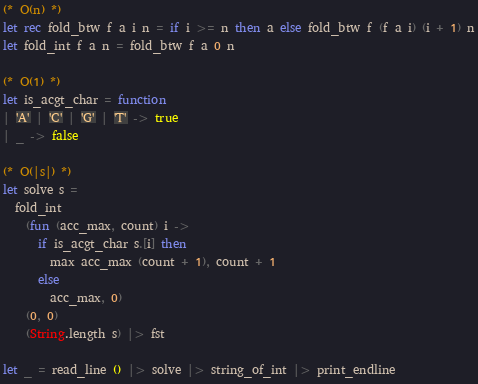<code> <loc_0><loc_0><loc_500><loc_500><_OCaml_>(* O(n) *)
let rec fold_btw f a i n = if i >= n then a else fold_btw f (f a i) (i + 1) n
let fold_int f a n = fold_btw f a 0 n

(* O(1) *)
let is_acgt_char = function
| 'A' | 'C' | 'G' | 'T' -> true
| _ -> false

(* O(|s|) *)
let solve s =
  fold_int
    (fun (acc_max, count) i ->
      if is_acgt_char s.[i] then
        max acc_max (count + 1), count + 1
      else
        acc_max, 0)
    (0, 0)
    (String.length s) |> fst

let _ = read_line () |> solve |> string_of_int |> print_endline</code> 